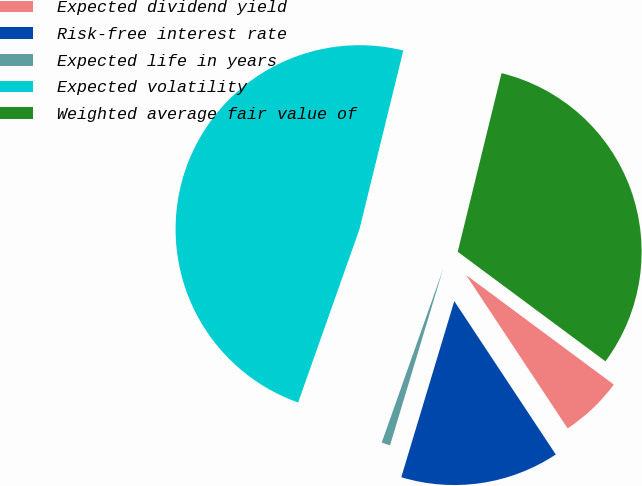Convert chart to OTSL. <chart><loc_0><loc_0><loc_500><loc_500><pie_chart><fcel>Expected dividend yield<fcel>Risk-free interest rate<fcel>Expected life in years<fcel>Expected volatility<fcel>Weighted average fair value of<nl><fcel>5.54%<fcel>13.96%<fcel>0.76%<fcel>48.42%<fcel>31.33%<nl></chart> 